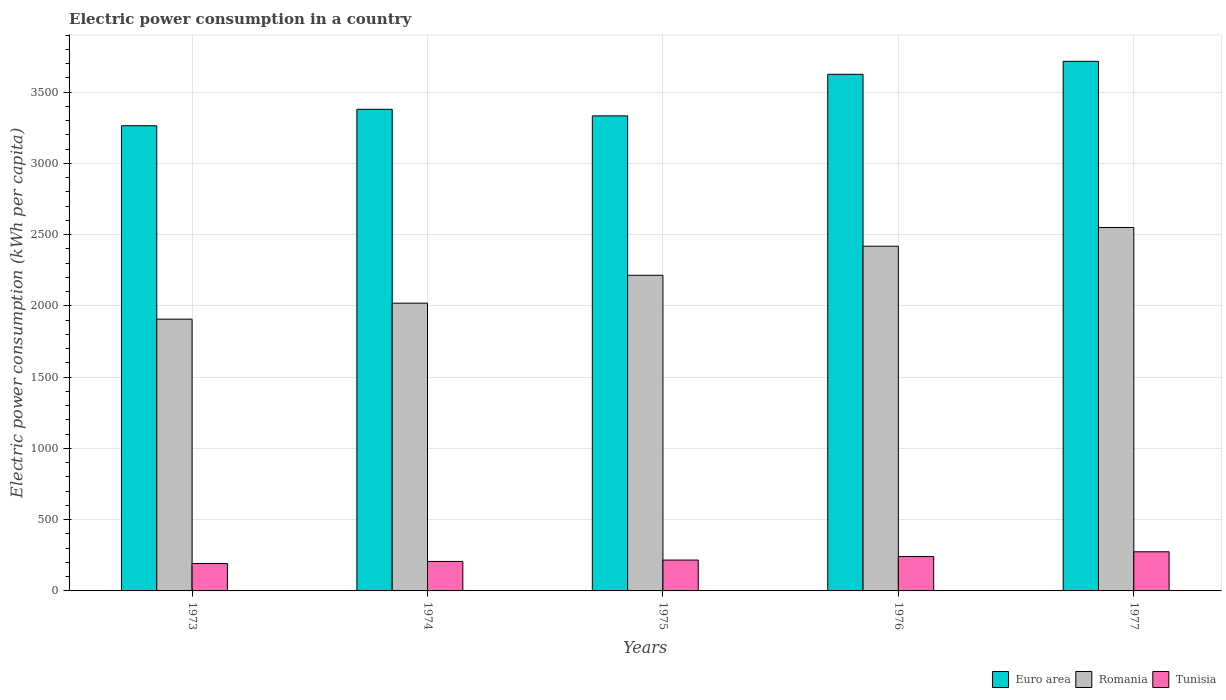Are the number of bars on each tick of the X-axis equal?
Make the answer very short. Yes. How many bars are there on the 4th tick from the left?
Give a very brief answer. 3. What is the label of the 3rd group of bars from the left?
Provide a short and direct response. 1975. In how many cases, is the number of bars for a given year not equal to the number of legend labels?
Your response must be concise. 0. What is the electric power consumption in in Tunisia in 1977?
Provide a succinct answer. 274.55. Across all years, what is the maximum electric power consumption in in Tunisia?
Your answer should be very brief. 274.55. Across all years, what is the minimum electric power consumption in in Tunisia?
Provide a succinct answer. 192.25. In which year was the electric power consumption in in Euro area maximum?
Offer a terse response. 1977. What is the total electric power consumption in in Euro area in the graph?
Offer a very short reply. 1.73e+04. What is the difference between the electric power consumption in in Romania in 1974 and that in 1977?
Offer a very short reply. -531.16. What is the difference between the electric power consumption in in Euro area in 1975 and the electric power consumption in in Romania in 1973?
Offer a very short reply. 1426.3. What is the average electric power consumption in in Tunisia per year?
Give a very brief answer. 226.23. In the year 1976, what is the difference between the electric power consumption in in Euro area and electric power consumption in in Tunisia?
Provide a succinct answer. 3383.78. In how many years, is the electric power consumption in in Euro area greater than 3400 kWh per capita?
Provide a succinct answer. 2. What is the ratio of the electric power consumption in in Euro area in 1973 to that in 1977?
Keep it short and to the point. 0.88. What is the difference between the highest and the second highest electric power consumption in in Tunisia?
Keep it short and to the point. 33.53. What is the difference between the highest and the lowest electric power consumption in in Tunisia?
Offer a terse response. 82.29. In how many years, is the electric power consumption in in Romania greater than the average electric power consumption in in Romania taken over all years?
Ensure brevity in your answer.  2. What does the 2nd bar from the left in 1973 represents?
Make the answer very short. Romania. What does the 2nd bar from the right in 1974 represents?
Offer a terse response. Romania. Are all the bars in the graph horizontal?
Provide a succinct answer. No. How many years are there in the graph?
Offer a terse response. 5. Does the graph contain grids?
Your answer should be very brief. Yes. How many legend labels are there?
Your answer should be very brief. 3. What is the title of the graph?
Keep it short and to the point. Electric power consumption in a country. Does "San Marino" appear as one of the legend labels in the graph?
Offer a terse response. No. What is the label or title of the Y-axis?
Provide a short and direct response. Electric power consumption (kWh per capita). What is the Electric power consumption (kWh per capita) in Euro area in 1973?
Offer a terse response. 3263.96. What is the Electric power consumption (kWh per capita) of Romania in 1973?
Keep it short and to the point. 1906.92. What is the Electric power consumption (kWh per capita) in Tunisia in 1973?
Provide a succinct answer. 192.25. What is the Electric power consumption (kWh per capita) of Euro area in 1974?
Offer a terse response. 3379.38. What is the Electric power consumption (kWh per capita) in Romania in 1974?
Your answer should be compact. 2018.98. What is the Electric power consumption (kWh per capita) of Tunisia in 1974?
Your answer should be very brief. 206.78. What is the Electric power consumption (kWh per capita) in Euro area in 1975?
Your answer should be very brief. 3333.22. What is the Electric power consumption (kWh per capita) of Romania in 1975?
Offer a terse response. 2214.61. What is the Electric power consumption (kWh per capita) in Tunisia in 1975?
Your answer should be compact. 216.54. What is the Electric power consumption (kWh per capita) in Euro area in 1976?
Ensure brevity in your answer.  3624.8. What is the Electric power consumption (kWh per capita) of Romania in 1976?
Offer a terse response. 2418.75. What is the Electric power consumption (kWh per capita) in Tunisia in 1976?
Keep it short and to the point. 241.02. What is the Electric power consumption (kWh per capita) in Euro area in 1977?
Give a very brief answer. 3715.69. What is the Electric power consumption (kWh per capita) in Romania in 1977?
Your response must be concise. 2550.14. What is the Electric power consumption (kWh per capita) in Tunisia in 1977?
Give a very brief answer. 274.55. Across all years, what is the maximum Electric power consumption (kWh per capita) of Euro area?
Your answer should be compact. 3715.69. Across all years, what is the maximum Electric power consumption (kWh per capita) of Romania?
Offer a very short reply. 2550.14. Across all years, what is the maximum Electric power consumption (kWh per capita) of Tunisia?
Your answer should be very brief. 274.55. Across all years, what is the minimum Electric power consumption (kWh per capita) of Euro area?
Ensure brevity in your answer.  3263.96. Across all years, what is the minimum Electric power consumption (kWh per capita) in Romania?
Give a very brief answer. 1906.92. Across all years, what is the minimum Electric power consumption (kWh per capita) of Tunisia?
Give a very brief answer. 192.25. What is the total Electric power consumption (kWh per capita) in Euro area in the graph?
Offer a terse response. 1.73e+04. What is the total Electric power consumption (kWh per capita) in Romania in the graph?
Ensure brevity in your answer.  1.11e+04. What is the total Electric power consumption (kWh per capita) of Tunisia in the graph?
Offer a very short reply. 1131.14. What is the difference between the Electric power consumption (kWh per capita) in Euro area in 1973 and that in 1974?
Provide a short and direct response. -115.42. What is the difference between the Electric power consumption (kWh per capita) in Romania in 1973 and that in 1974?
Provide a succinct answer. -112.06. What is the difference between the Electric power consumption (kWh per capita) of Tunisia in 1973 and that in 1974?
Your answer should be compact. -14.53. What is the difference between the Electric power consumption (kWh per capita) of Euro area in 1973 and that in 1975?
Offer a very short reply. -69.26. What is the difference between the Electric power consumption (kWh per capita) of Romania in 1973 and that in 1975?
Provide a succinct answer. -307.69. What is the difference between the Electric power consumption (kWh per capita) in Tunisia in 1973 and that in 1975?
Give a very brief answer. -24.29. What is the difference between the Electric power consumption (kWh per capita) in Euro area in 1973 and that in 1976?
Provide a succinct answer. -360.84. What is the difference between the Electric power consumption (kWh per capita) in Romania in 1973 and that in 1976?
Offer a very short reply. -511.83. What is the difference between the Electric power consumption (kWh per capita) in Tunisia in 1973 and that in 1976?
Your response must be concise. -48.76. What is the difference between the Electric power consumption (kWh per capita) of Euro area in 1973 and that in 1977?
Make the answer very short. -451.74. What is the difference between the Electric power consumption (kWh per capita) in Romania in 1973 and that in 1977?
Make the answer very short. -643.21. What is the difference between the Electric power consumption (kWh per capita) in Tunisia in 1973 and that in 1977?
Your answer should be compact. -82.29. What is the difference between the Electric power consumption (kWh per capita) of Euro area in 1974 and that in 1975?
Provide a succinct answer. 46.16. What is the difference between the Electric power consumption (kWh per capita) of Romania in 1974 and that in 1975?
Your answer should be compact. -195.63. What is the difference between the Electric power consumption (kWh per capita) of Tunisia in 1974 and that in 1975?
Your response must be concise. -9.76. What is the difference between the Electric power consumption (kWh per capita) in Euro area in 1974 and that in 1976?
Offer a very short reply. -245.42. What is the difference between the Electric power consumption (kWh per capita) of Romania in 1974 and that in 1976?
Your answer should be compact. -399.77. What is the difference between the Electric power consumption (kWh per capita) of Tunisia in 1974 and that in 1976?
Give a very brief answer. -34.24. What is the difference between the Electric power consumption (kWh per capita) in Euro area in 1974 and that in 1977?
Provide a succinct answer. -336.32. What is the difference between the Electric power consumption (kWh per capita) in Romania in 1974 and that in 1977?
Provide a short and direct response. -531.16. What is the difference between the Electric power consumption (kWh per capita) of Tunisia in 1974 and that in 1977?
Offer a very short reply. -67.77. What is the difference between the Electric power consumption (kWh per capita) of Euro area in 1975 and that in 1976?
Offer a terse response. -291.58. What is the difference between the Electric power consumption (kWh per capita) of Romania in 1975 and that in 1976?
Your response must be concise. -204.14. What is the difference between the Electric power consumption (kWh per capita) in Tunisia in 1975 and that in 1976?
Your answer should be compact. -24.48. What is the difference between the Electric power consumption (kWh per capita) of Euro area in 1975 and that in 1977?
Ensure brevity in your answer.  -382.48. What is the difference between the Electric power consumption (kWh per capita) in Romania in 1975 and that in 1977?
Make the answer very short. -335.52. What is the difference between the Electric power consumption (kWh per capita) in Tunisia in 1975 and that in 1977?
Offer a terse response. -58.01. What is the difference between the Electric power consumption (kWh per capita) of Euro area in 1976 and that in 1977?
Provide a succinct answer. -90.89. What is the difference between the Electric power consumption (kWh per capita) in Romania in 1976 and that in 1977?
Your answer should be compact. -131.39. What is the difference between the Electric power consumption (kWh per capita) in Tunisia in 1976 and that in 1977?
Provide a short and direct response. -33.53. What is the difference between the Electric power consumption (kWh per capita) in Euro area in 1973 and the Electric power consumption (kWh per capita) in Romania in 1974?
Make the answer very short. 1244.98. What is the difference between the Electric power consumption (kWh per capita) in Euro area in 1973 and the Electric power consumption (kWh per capita) in Tunisia in 1974?
Ensure brevity in your answer.  3057.18. What is the difference between the Electric power consumption (kWh per capita) in Romania in 1973 and the Electric power consumption (kWh per capita) in Tunisia in 1974?
Offer a terse response. 1700.14. What is the difference between the Electric power consumption (kWh per capita) in Euro area in 1973 and the Electric power consumption (kWh per capita) in Romania in 1975?
Your answer should be very brief. 1049.35. What is the difference between the Electric power consumption (kWh per capita) in Euro area in 1973 and the Electric power consumption (kWh per capita) in Tunisia in 1975?
Keep it short and to the point. 3047.42. What is the difference between the Electric power consumption (kWh per capita) in Romania in 1973 and the Electric power consumption (kWh per capita) in Tunisia in 1975?
Offer a terse response. 1690.38. What is the difference between the Electric power consumption (kWh per capita) of Euro area in 1973 and the Electric power consumption (kWh per capita) of Romania in 1976?
Provide a succinct answer. 845.21. What is the difference between the Electric power consumption (kWh per capita) in Euro area in 1973 and the Electric power consumption (kWh per capita) in Tunisia in 1976?
Your response must be concise. 3022.94. What is the difference between the Electric power consumption (kWh per capita) of Romania in 1973 and the Electric power consumption (kWh per capita) of Tunisia in 1976?
Offer a terse response. 1665.9. What is the difference between the Electric power consumption (kWh per capita) in Euro area in 1973 and the Electric power consumption (kWh per capita) in Romania in 1977?
Make the answer very short. 713.82. What is the difference between the Electric power consumption (kWh per capita) of Euro area in 1973 and the Electric power consumption (kWh per capita) of Tunisia in 1977?
Provide a succinct answer. 2989.41. What is the difference between the Electric power consumption (kWh per capita) of Romania in 1973 and the Electric power consumption (kWh per capita) of Tunisia in 1977?
Give a very brief answer. 1632.37. What is the difference between the Electric power consumption (kWh per capita) of Euro area in 1974 and the Electric power consumption (kWh per capita) of Romania in 1975?
Your answer should be very brief. 1164.77. What is the difference between the Electric power consumption (kWh per capita) of Euro area in 1974 and the Electric power consumption (kWh per capita) of Tunisia in 1975?
Your answer should be very brief. 3162.84. What is the difference between the Electric power consumption (kWh per capita) in Romania in 1974 and the Electric power consumption (kWh per capita) in Tunisia in 1975?
Your answer should be compact. 1802.44. What is the difference between the Electric power consumption (kWh per capita) of Euro area in 1974 and the Electric power consumption (kWh per capita) of Romania in 1976?
Ensure brevity in your answer.  960.63. What is the difference between the Electric power consumption (kWh per capita) of Euro area in 1974 and the Electric power consumption (kWh per capita) of Tunisia in 1976?
Offer a very short reply. 3138.36. What is the difference between the Electric power consumption (kWh per capita) of Romania in 1974 and the Electric power consumption (kWh per capita) of Tunisia in 1976?
Your response must be concise. 1777.96. What is the difference between the Electric power consumption (kWh per capita) of Euro area in 1974 and the Electric power consumption (kWh per capita) of Romania in 1977?
Your answer should be compact. 829.24. What is the difference between the Electric power consumption (kWh per capita) in Euro area in 1974 and the Electric power consumption (kWh per capita) in Tunisia in 1977?
Provide a succinct answer. 3104.83. What is the difference between the Electric power consumption (kWh per capita) in Romania in 1974 and the Electric power consumption (kWh per capita) in Tunisia in 1977?
Keep it short and to the point. 1744.43. What is the difference between the Electric power consumption (kWh per capita) in Euro area in 1975 and the Electric power consumption (kWh per capita) in Romania in 1976?
Your answer should be compact. 914.47. What is the difference between the Electric power consumption (kWh per capita) of Euro area in 1975 and the Electric power consumption (kWh per capita) of Tunisia in 1976?
Give a very brief answer. 3092.2. What is the difference between the Electric power consumption (kWh per capita) of Romania in 1975 and the Electric power consumption (kWh per capita) of Tunisia in 1976?
Give a very brief answer. 1973.59. What is the difference between the Electric power consumption (kWh per capita) in Euro area in 1975 and the Electric power consumption (kWh per capita) in Romania in 1977?
Ensure brevity in your answer.  783.08. What is the difference between the Electric power consumption (kWh per capita) in Euro area in 1975 and the Electric power consumption (kWh per capita) in Tunisia in 1977?
Provide a succinct answer. 3058.67. What is the difference between the Electric power consumption (kWh per capita) of Romania in 1975 and the Electric power consumption (kWh per capita) of Tunisia in 1977?
Provide a short and direct response. 1940.06. What is the difference between the Electric power consumption (kWh per capita) of Euro area in 1976 and the Electric power consumption (kWh per capita) of Romania in 1977?
Make the answer very short. 1074.67. What is the difference between the Electric power consumption (kWh per capita) in Euro area in 1976 and the Electric power consumption (kWh per capita) in Tunisia in 1977?
Give a very brief answer. 3350.25. What is the difference between the Electric power consumption (kWh per capita) in Romania in 1976 and the Electric power consumption (kWh per capita) in Tunisia in 1977?
Offer a terse response. 2144.2. What is the average Electric power consumption (kWh per capita) of Euro area per year?
Your answer should be very brief. 3463.41. What is the average Electric power consumption (kWh per capita) of Romania per year?
Give a very brief answer. 2221.88. What is the average Electric power consumption (kWh per capita) of Tunisia per year?
Offer a very short reply. 226.23. In the year 1973, what is the difference between the Electric power consumption (kWh per capita) of Euro area and Electric power consumption (kWh per capita) of Romania?
Offer a terse response. 1357.04. In the year 1973, what is the difference between the Electric power consumption (kWh per capita) of Euro area and Electric power consumption (kWh per capita) of Tunisia?
Provide a short and direct response. 3071.71. In the year 1973, what is the difference between the Electric power consumption (kWh per capita) of Romania and Electric power consumption (kWh per capita) of Tunisia?
Your answer should be very brief. 1714.67. In the year 1974, what is the difference between the Electric power consumption (kWh per capita) in Euro area and Electric power consumption (kWh per capita) in Romania?
Your answer should be very brief. 1360.4. In the year 1974, what is the difference between the Electric power consumption (kWh per capita) in Euro area and Electric power consumption (kWh per capita) in Tunisia?
Provide a succinct answer. 3172.6. In the year 1974, what is the difference between the Electric power consumption (kWh per capita) in Romania and Electric power consumption (kWh per capita) in Tunisia?
Your answer should be very brief. 1812.2. In the year 1975, what is the difference between the Electric power consumption (kWh per capita) of Euro area and Electric power consumption (kWh per capita) of Romania?
Your answer should be compact. 1118.61. In the year 1975, what is the difference between the Electric power consumption (kWh per capita) in Euro area and Electric power consumption (kWh per capita) in Tunisia?
Make the answer very short. 3116.68. In the year 1975, what is the difference between the Electric power consumption (kWh per capita) in Romania and Electric power consumption (kWh per capita) in Tunisia?
Offer a terse response. 1998.07. In the year 1976, what is the difference between the Electric power consumption (kWh per capita) in Euro area and Electric power consumption (kWh per capita) in Romania?
Keep it short and to the point. 1206.05. In the year 1976, what is the difference between the Electric power consumption (kWh per capita) in Euro area and Electric power consumption (kWh per capita) in Tunisia?
Your response must be concise. 3383.78. In the year 1976, what is the difference between the Electric power consumption (kWh per capita) of Romania and Electric power consumption (kWh per capita) of Tunisia?
Your answer should be compact. 2177.73. In the year 1977, what is the difference between the Electric power consumption (kWh per capita) of Euro area and Electric power consumption (kWh per capita) of Romania?
Provide a succinct answer. 1165.56. In the year 1977, what is the difference between the Electric power consumption (kWh per capita) in Euro area and Electric power consumption (kWh per capita) in Tunisia?
Give a very brief answer. 3441.15. In the year 1977, what is the difference between the Electric power consumption (kWh per capita) of Romania and Electric power consumption (kWh per capita) of Tunisia?
Offer a very short reply. 2275.59. What is the ratio of the Electric power consumption (kWh per capita) of Euro area in 1973 to that in 1974?
Make the answer very short. 0.97. What is the ratio of the Electric power consumption (kWh per capita) in Romania in 1973 to that in 1974?
Give a very brief answer. 0.94. What is the ratio of the Electric power consumption (kWh per capita) in Tunisia in 1973 to that in 1974?
Your response must be concise. 0.93. What is the ratio of the Electric power consumption (kWh per capita) in Euro area in 1973 to that in 1975?
Your answer should be compact. 0.98. What is the ratio of the Electric power consumption (kWh per capita) in Romania in 1973 to that in 1975?
Your answer should be compact. 0.86. What is the ratio of the Electric power consumption (kWh per capita) of Tunisia in 1973 to that in 1975?
Provide a short and direct response. 0.89. What is the ratio of the Electric power consumption (kWh per capita) in Euro area in 1973 to that in 1976?
Offer a terse response. 0.9. What is the ratio of the Electric power consumption (kWh per capita) in Romania in 1973 to that in 1976?
Provide a short and direct response. 0.79. What is the ratio of the Electric power consumption (kWh per capita) in Tunisia in 1973 to that in 1976?
Keep it short and to the point. 0.8. What is the ratio of the Electric power consumption (kWh per capita) of Euro area in 1973 to that in 1977?
Your answer should be compact. 0.88. What is the ratio of the Electric power consumption (kWh per capita) of Romania in 1973 to that in 1977?
Your answer should be compact. 0.75. What is the ratio of the Electric power consumption (kWh per capita) of Tunisia in 1973 to that in 1977?
Ensure brevity in your answer.  0.7. What is the ratio of the Electric power consumption (kWh per capita) of Euro area in 1974 to that in 1975?
Your answer should be very brief. 1.01. What is the ratio of the Electric power consumption (kWh per capita) of Romania in 1974 to that in 1975?
Offer a terse response. 0.91. What is the ratio of the Electric power consumption (kWh per capita) in Tunisia in 1974 to that in 1975?
Ensure brevity in your answer.  0.95. What is the ratio of the Electric power consumption (kWh per capita) in Euro area in 1974 to that in 1976?
Your answer should be compact. 0.93. What is the ratio of the Electric power consumption (kWh per capita) of Romania in 1974 to that in 1976?
Provide a short and direct response. 0.83. What is the ratio of the Electric power consumption (kWh per capita) in Tunisia in 1974 to that in 1976?
Provide a short and direct response. 0.86. What is the ratio of the Electric power consumption (kWh per capita) of Euro area in 1974 to that in 1977?
Give a very brief answer. 0.91. What is the ratio of the Electric power consumption (kWh per capita) in Romania in 1974 to that in 1977?
Ensure brevity in your answer.  0.79. What is the ratio of the Electric power consumption (kWh per capita) in Tunisia in 1974 to that in 1977?
Offer a terse response. 0.75. What is the ratio of the Electric power consumption (kWh per capita) of Euro area in 1975 to that in 1976?
Offer a very short reply. 0.92. What is the ratio of the Electric power consumption (kWh per capita) in Romania in 1975 to that in 1976?
Your response must be concise. 0.92. What is the ratio of the Electric power consumption (kWh per capita) of Tunisia in 1975 to that in 1976?
Give a very brief answer. 0.9. What is the ratio of the Electric power consumption (kWh per capita) in Euro area in 1975 to that in 1977?
Your answer should be very brief. 0.9. What is the ratio of the Electric power consumption (kWh per capita) in Romania in 1975 to that in 1977?
Make the answer very short. 0.87. What is the ratio of the Electric power consumption (kWh per capita) in Tunisia in 1975 to that in 1977?
Provide a short and direct response. 0.79. What is the ratio of the Electric power consumption (kWh per capita) of Euro area in 1976 to that in 1977?
Your response must be concise. 0.98. What is the ratio of the Electric power consumption (kWh per capita) in Romania in 1976 to that in 1977?
Provide a succinct answer. 0.95. What is the ratio of the Electric power consumption (kWh per capita) in Tunisia in 1976 to that in 1977?
Keep it short and to the point. 0.88. What is the difference between the highest and the second highest Electric power consumption (kWh per capita) of Euro area?
Offer a very short reply. 90.89. What is the difference between the highest and the second highest Electric power consumption (kWh per capita) of Romania?
Provide a succinct answer. 131.39. What is the difference between the highest and the second highest Electric power consumption (kWh per capita) in Tunisia?
Your answer should be very brief. 33.53. What is the difference between the highest and the lowest Electric power consumption (kWh per capita) of Euro area?
Offer a terse response. 451.74. What is the difference between the highest and the lowest Electric power consumption (kWh per capita) of Romania?
Keep it short and to the point. 643.21. What is the difference between the highest and the lowest Electric power consumption (kWh per capita) in Tunisia?
Provide a short and direct response. 82.29. 